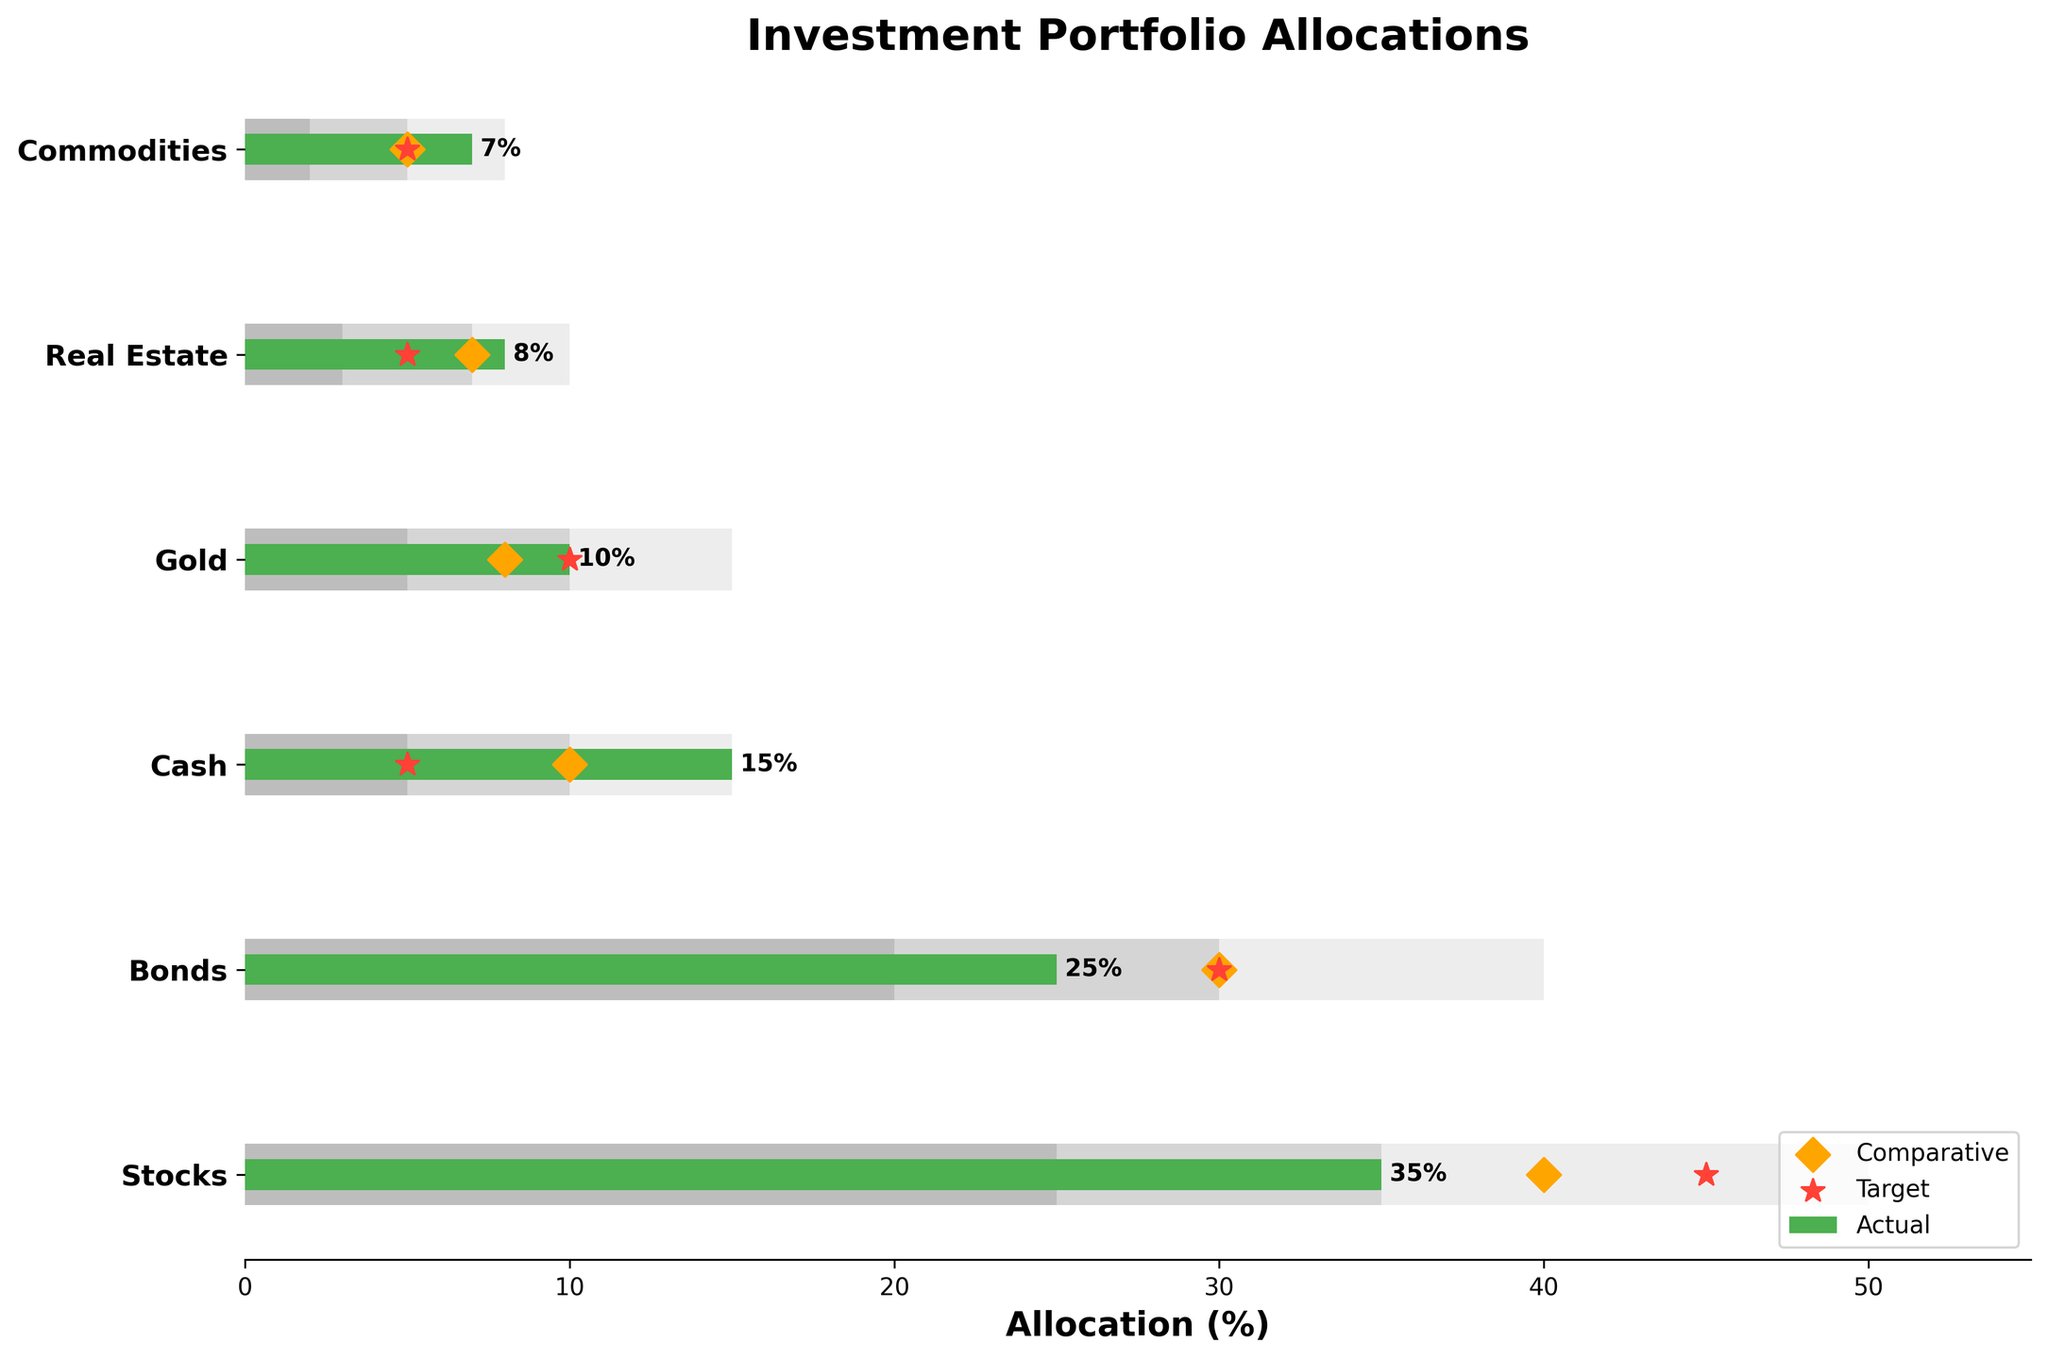what is the title of the figure? The title is located at the top of the figure and typically provides an overview of the content being presented. In this case, the title is "Investment Portfolio Allocations".
Answer: Investment Portfolio Allocations Which category has the highest actual allocation? The actual allocation values are represented by the green bars in the figure, and the category with the longest green bar will have the highest actual allocation. For Stocks, the bar is at 35% which is the highest among all categories.
Answer: Stocks What is the target allocation for Bonds? The target allocation is represented by red stars on the figure. For the Bonds category, the red star is at 30%, indicating the target allocation.
Answer: 30% What is the difference between the actual and comparative allocation for Real Estate? The actual allocation for Real Estate is 8%, represented by the green bar, while the comparative allocation is 7%, indicated by the orange diamond. Subtracting the comparative allocation from the actual allocation gives 8% - 7% = 1%.
Answer: 1% Which category has the smallest range for Range3? Range3 are represented by the lightest bars in the background. By comparing the lengths, Real Estate has the smallest Range3 with 10%.
Answer: Real Estate How many categories have their actual allocation greater than their comparative allocation? By comparing the green bars (actual allocation) versus the orange diamonds (comparative allocation) for each category, we see that Stocks, Cash, Gold, Real Estate, and Commodities have their actual allocation greater than their comparative allocation. This results in 5 categories.
Answer: 5 In which category is the actual allocation exactly equal to the target allocation? The target allocations are represented by red stars, and where the green bar (actual allocation) aligns exactly with the red star is the Gold category, both at 10%.
Answer: Gold By how much does the actual allocation for Commodities exceed its target allocation? The actual allocation for Commodities is shown as 7% (green bar) and the target allocation is 5% (red star). The exceedance is calculated as 7% - 5% = 2%.
Answer: 2% What is the average target allocation across all categories? The target allocations are: Stocks (45%), Bonds (30%), Cash (5%), Gold (10%), Real Estate (5%), and Commodities (5%). Summing these values: 45 + 30 + 5 + 10 + 5 + 5 = 100. There are 6 categories, so the average is 100 / 6 ≈ 16.67%.
Answer: 16.67% Which categories have a larger range in Range2 compared to their Range1? The ranges are represented by the shaded backgrounds where Range2 is darker than Range1. Comparing the Range1 and Range2 values for each category: Stocks (Range2 = 35%, Range1 = 25%), Bonds (Range2 = 30%, Range1 = 20%), Cash (Range2 = 10%, Range1 = 5%), Gold (Range2 = 10%, Range1 = 5%), Real Estate (Range2 = 7%, Range1 = 3%), Commodities (Range2 = 5%, Range1 = 2%). So, Stocks, Bonds, Cash, and Gold have a larger Range2 compared to Range1.
Answer: Stocks, Bonds, Cash, Gold 